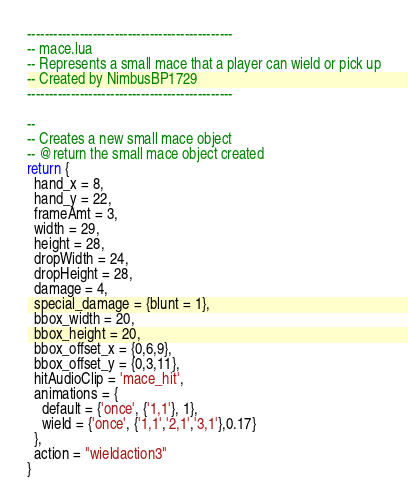Convert code to text. <code><loc_0><loc_0><loc_500><loc_500><_Lua_>-----------------------------------------------
-- mace.lua
-- Represents a small mace that a player can wield or pick up
-- Created by NimbusBP1729
-----------------------------------------------

--
-- Creates a new small mace object
-- @return the small mace object created
return {
  hand_x = 8,
  hand_y = 22,
  frameAmt = 3,
  width = 29,
  height = 28,
  dropWidth = 24,
  dropHeight = 28,
  damage = 4,
  special_damage = {blunt = 1},
  bbox_width = 20,
  bbox_height = 20,
  bbox_offset_x = {0,6,9},
  bbox_offset_y = {0,3,11},
  hitAudioClip = 'mace_hit',
  animations = {
    default = {'once', {'1,1'}, 1},
    wield = {'once', {'1,1','2,1','3,1'},0.17}
  },
  action = "wieldaction3"
}
</code> 